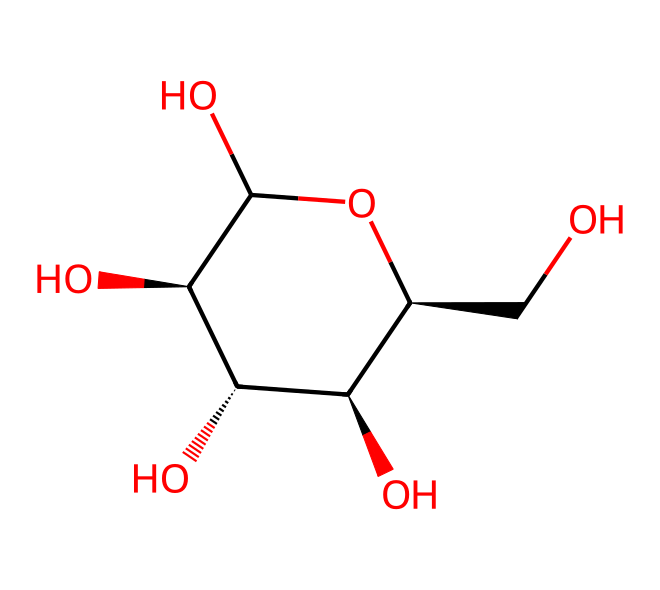How many carbon atoms are in glucose? The SMILES representation shows "C" symbols, indicating the presence of carbon atoms in the structure. Counting these "C" symbols results in six carbon atoms.
Answer: six What is the molecular formula for glucose? To derive the molecular formula, count the total number of carbon (C), hydrogen (H), and oxygen (O) atoms in the structure. The counts reveal there are six carbons, twelve hydrogens, and six oxygens, leading to the molecular formula C6H12O6.
Answer: C6H12O6 Is glucose a reducing sugar? Glucose contains a free aldehyde group, typical in monosaccharides, allowing it to act as a reducing sugar by donating electrons. This feature makes it capable of reducing other compounds.
Answer: yes What type of functional groups are present in glucose? Analyzing the structure, glucose features hydroxyl (-OH) groups, identified by the "O" connected to "C." These hydroxyl groups are key in defining it as an alcohol, in addition to the aldehyde functional group at one end.
Answer: hydroxyl and aldehyde How many hydroxyl groups are in glucose? Within the structure, each "O" connected directly to a "C" represents a hydroxyl group. Counting these connections shows there are five hydroxyl groups attached to the carbon atoms.
Answer: five What stereochemistry situation is observed in glucose? The presence of chiral centers is identified where a carbon atom has four different substituents, seen in several carbon atoms in the structure. Specifically, there are four chiral centers indicating stereochemical variability.
Answer: four Which form of glucose is more common in nature? The structural representation indicates an open-chain form. However, due to the stability and prevalence of the cyclic form in solution, the pyranose form is the most common in nature.
Answer: pyranose 